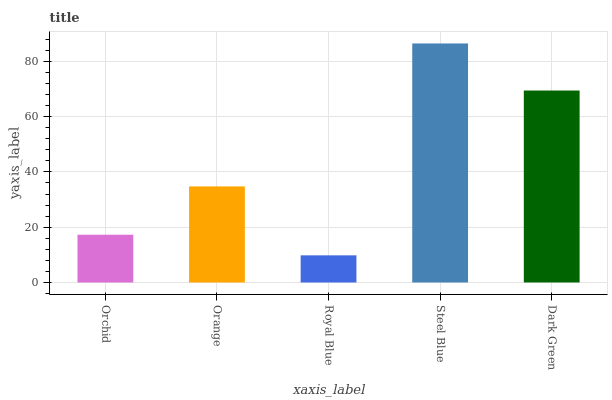Is Orange the minimum?
Answer yes or no. No. Is Orange the maximum?
Answer yes or no. No. Is Orange greater than Orchid?
Answer yes or no. Yes. Is Orchid less than Orange?
Answer yes or no. Yes. Is Orchid greater than Orange?
Answer yes or no. No. Is Orange less than Orchid?
Answer yes or no. No. Is Orange the high median?
Answer yes or no. Yes. Is Orange the low median?
Answer yes or no. Yes. Is Orchid the high median?
Answer yes or no. No. Is Royal Blue the low median?
Answer yes or no. No. 